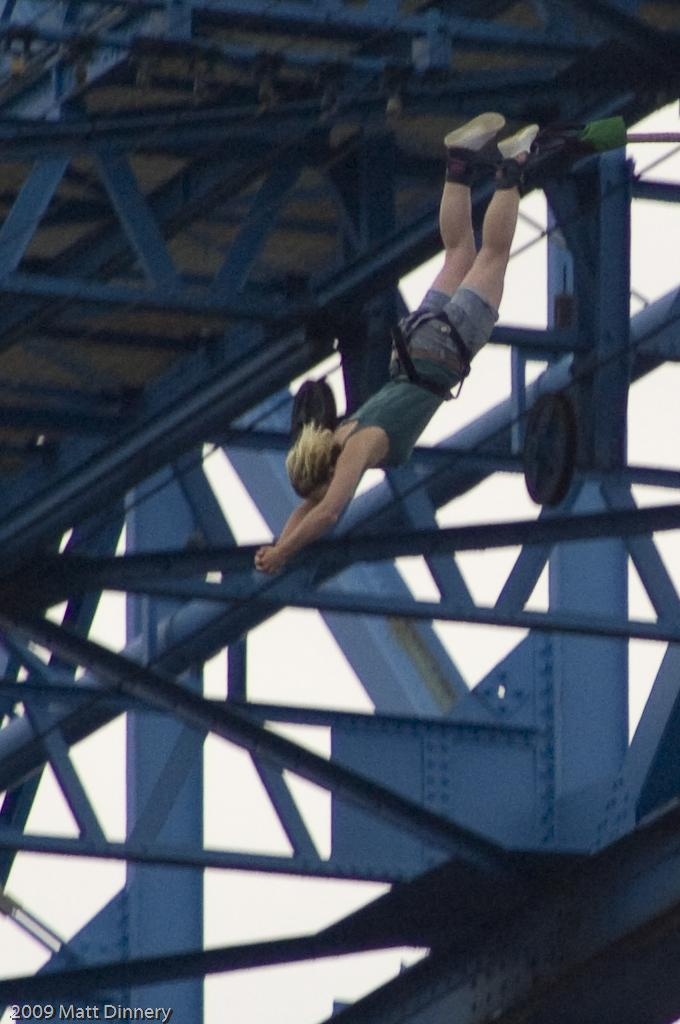Who is the main subject in the image? There is a woman in the image. What is the woman doing in the image? The woman is bungee jumping. What structure is present in the image? There is a bridge in the image. How would you describe the weather in the image? The sky is cloudy in the image. Where is the sack of potatoes stored in the image? There is no sack of potatoes present in the image. What type of cave can be seen in the background of the image? There is no cave visible in the image; it features a woman bungee jumping from a bridge with a cloudy sky. 